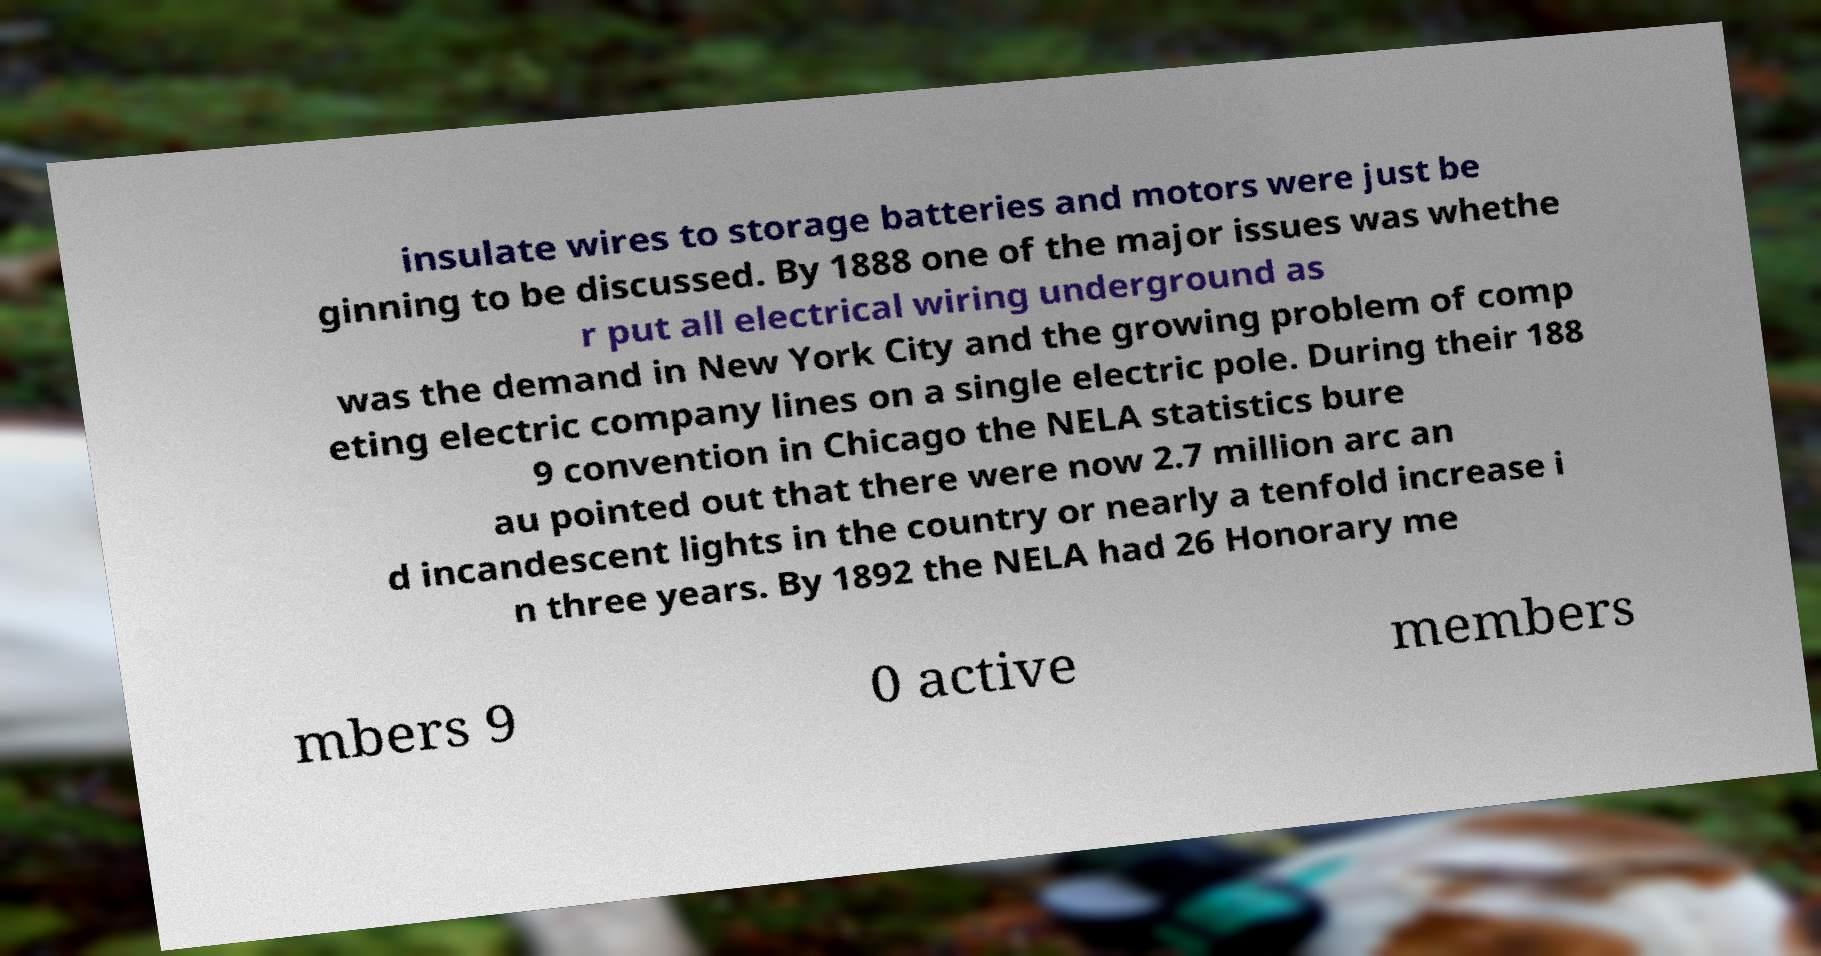What messages or text are displayed in this image? I need them in a readable, typed format. insulate wires to storage batteries and motors were just be ginning to be discussed. By 1888 one of the major issues was whethe r put all electrical wiring underground as was the demand in New York City and the growing problem of comp eting electric company lines on a single electric pole. During their 188 9 convention in Chicago the NELA statistics bure au pointed out that there were now 2.7 million arc an d incandescent lights in the country or nearly a tenfold increase i n three years. By 1892 the NELA had 26 Honorary me mbers 9 0 active members 